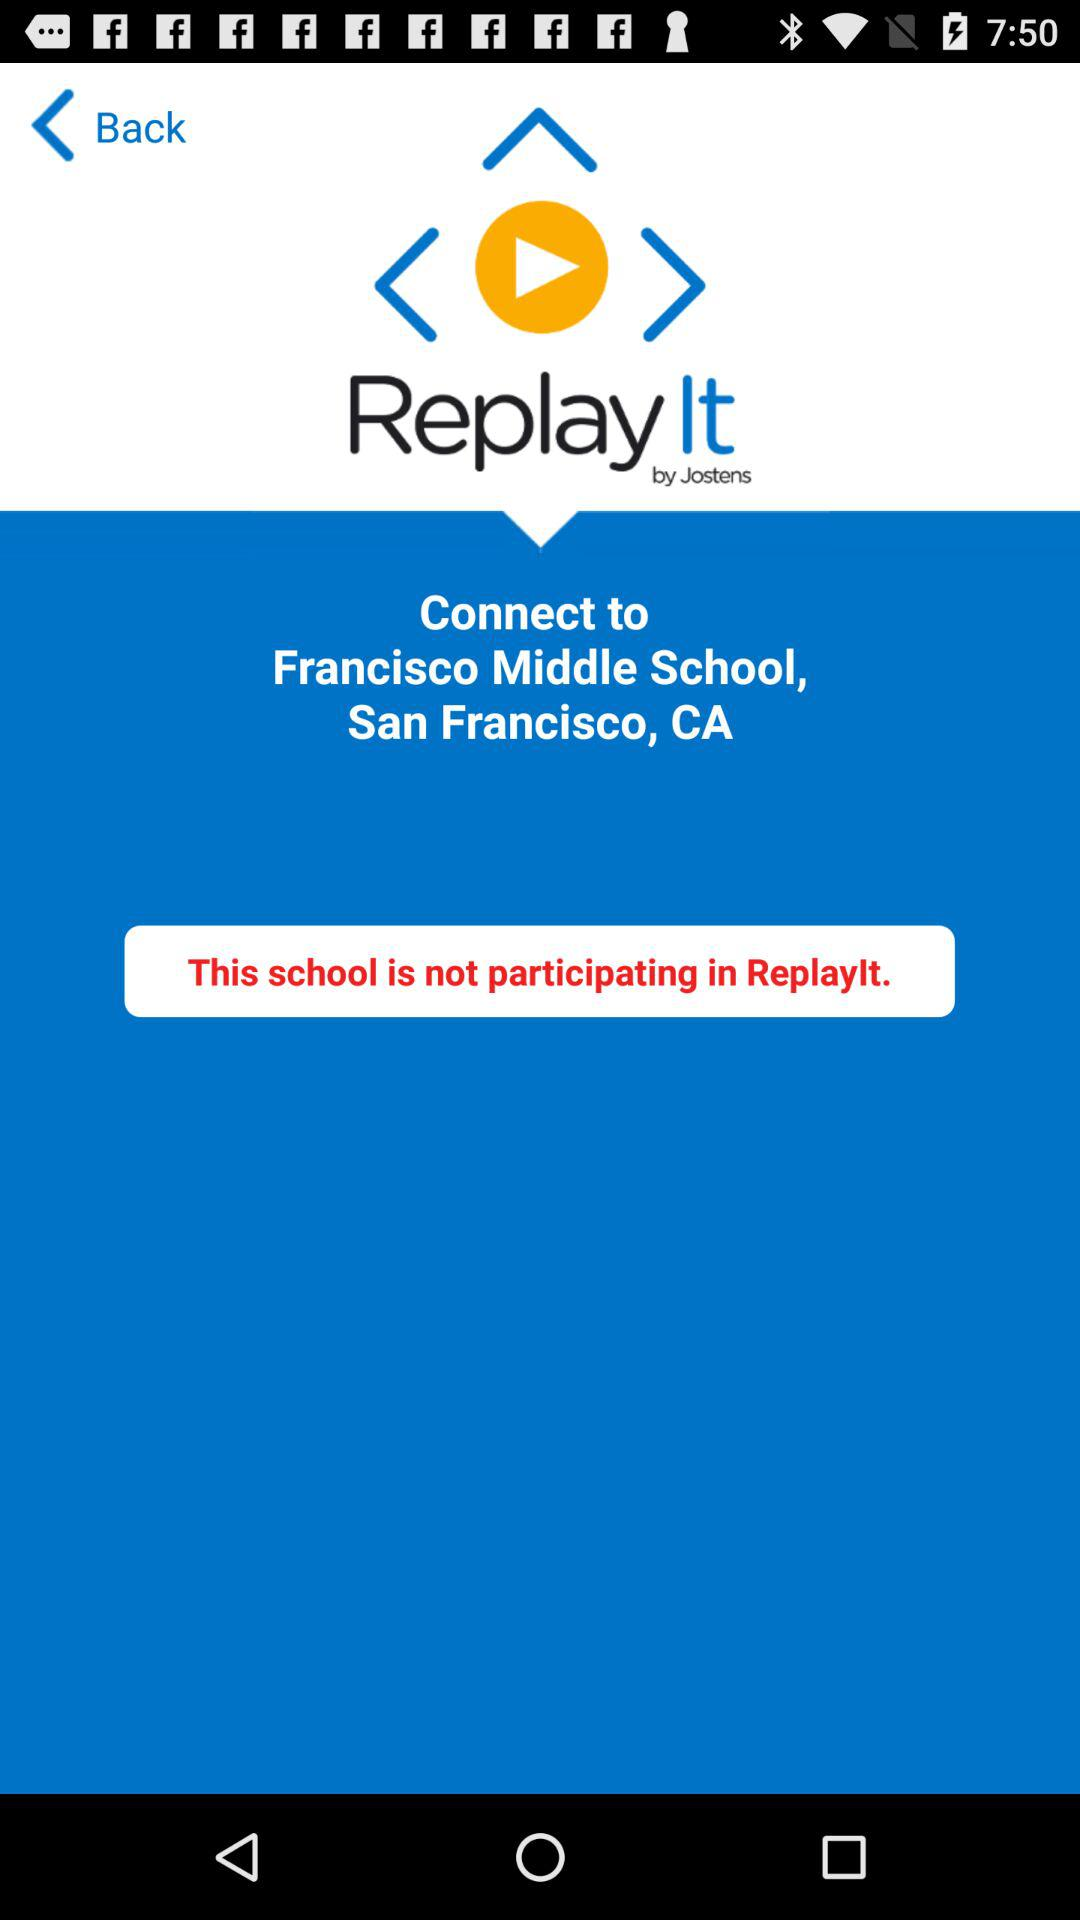Who developed the application? The application was developed by "Jostens". 